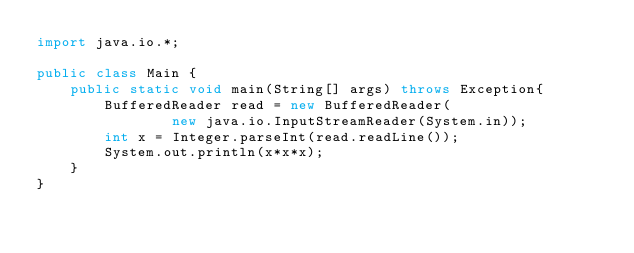<code> <loc_0><loc_0><loc_500><loc_500><_Java_>import java.io.*;
 
public class Main {
    public static void main(String[] args) throws Exception{
        BufferedReader read = new BufferedReader(
                new java.io.InputStreamReader(System.in));
        int x = Integer.parseInt(read.readLine());
        System.out.println(x*x*x);
    }
}</code> 